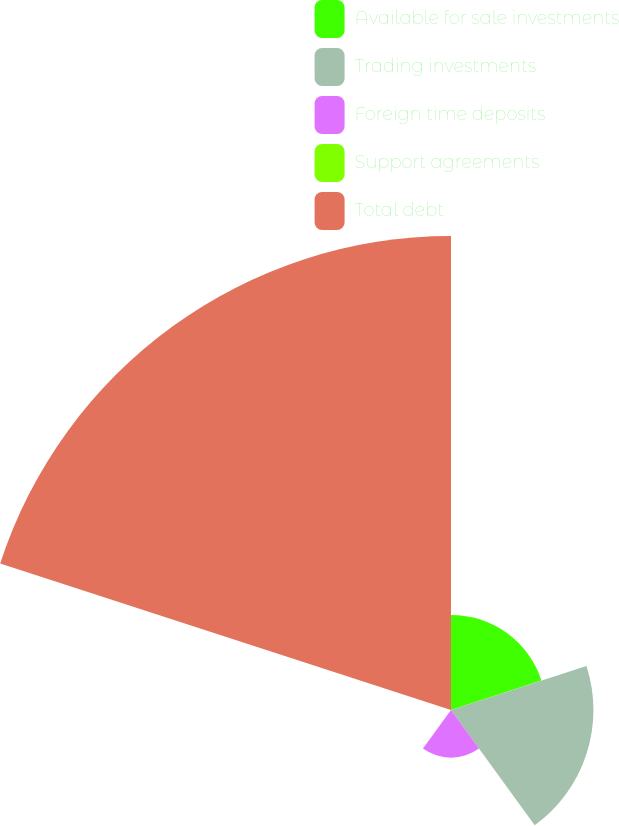<chart> <loc_0><loc_0><loc_500><loc_500><pie_chart><fcel>Available for sale investments<fcel>Trading investments<fcel>Foreign time deposits<fcel>Support agreements<fcel>Total debt<nl><fcel>12.52%<fcel>18.75%<fcel>6.28%<fcel>0.05%<fcel>62.4%<nl></chart> 